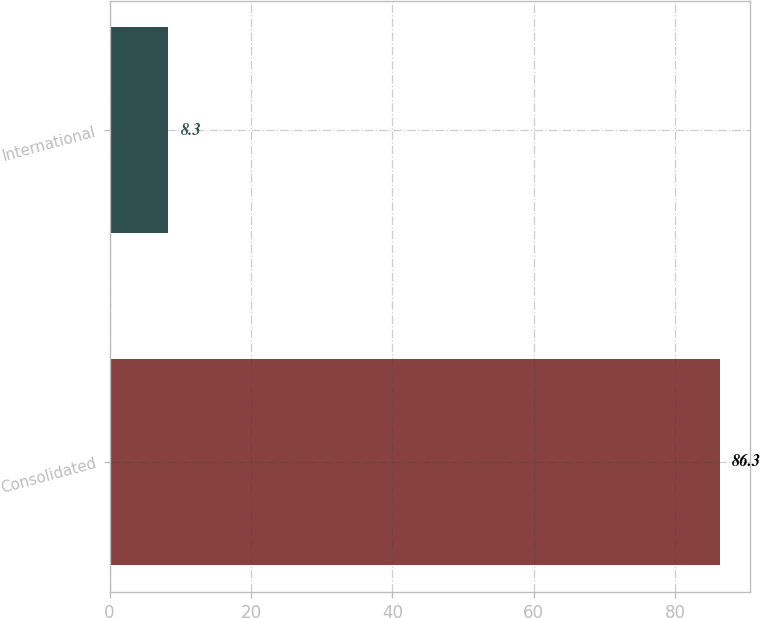<chart> <loc_0><loc_0><loc_500><loc_500><bar_chart><fcel>Consolidated<fcel>International<nl><fcel>86.3<fcel>8.3<nl></chart> 